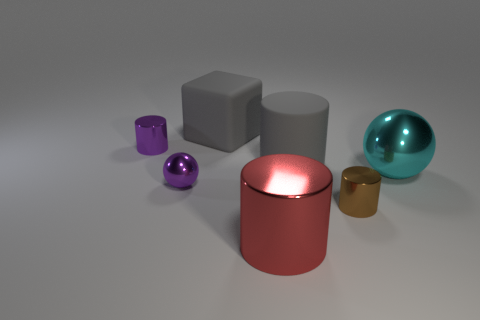How many small blue rubber objects are there?
Provide a short and direct response. 0. What is the size of the rubber object in front of the matte block?
Offer a terse response. Large. Is the red shiny thing the same size as the cyan metallic object?
Ensure brevity in your answer.  Yes. What number of things are tiny red matte balls or tiny metal objects that are to the right of the big matte block?
Keep it short and to the point. 1. What is the material of the red cylinder?
Your answer should be very brief. Metal. Are there any other things that have the same color as the big rubber block?
Provide a short and direct response. Yes. Do the big red metallic object and the brown shiny thing have the same shape?
Make the answer very short. Yes. There is a purple thing on the right side of the purple cylinder behind the metal ball that is right of the tiny brown cylinder; what is its size?
Provide a succinct answer. Small. What number of other things are made of the same material as the large ball?
Give a very brief answer. 4. There is a cylinder to the left of the big gray cube; what color is it?
Offer a very short reply. Purple. 